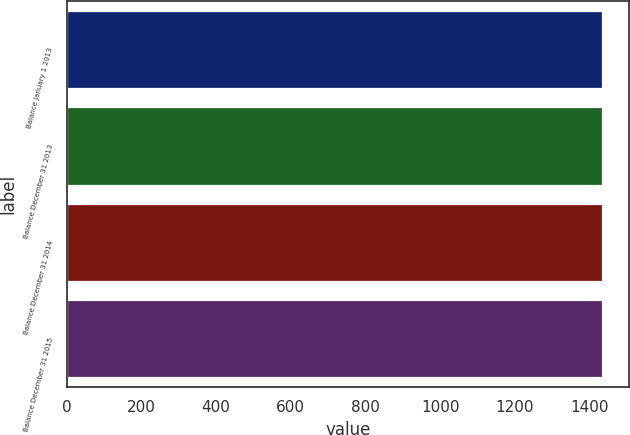Convert chart. <chart><loc_0><loc_0><loc_500><loc_500><bar_chart><fcel>Balance January 1 2013<fcel>Balance December 31 2013<fcel>Balance December 31 2014<fcel>Balance December 31 2015<nl><fcel>1434<fcel>1434.1<fcel>1434.2<fcel>1434.3<nl></chart> 